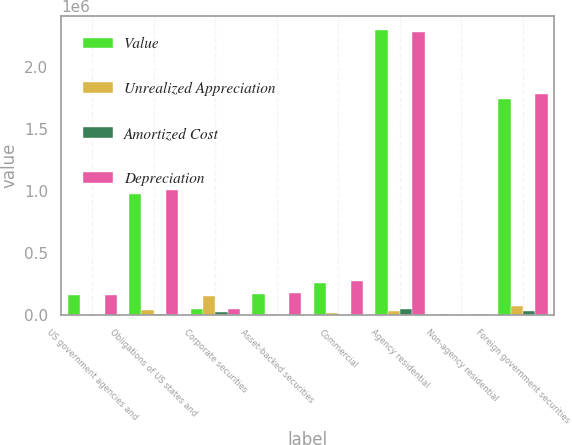Convert chart. <chart><loc_0><loc_0><loc_500><loc_500><stacked_bar_chart><ecel><fcel>US government agencies and<fcel>Obligations of US states and<fcel>Corporate securities<fcel>Asset-backed securities<fcel>Commercial<fcel>Agency residential<fcel>Non-agency residential<fcel>Foreign government securities<nl><fcel>Value<fcel>160013<fcel>970735<fcel>45495<fcel>169980<fcel>254765<fcel>2.29472e+06<fcel>4816<fcel>1.74034e+06<nl><fcel>Unrealized Appreciation<fcel>2690<fcel>40815<fcel>155619<fcel>3485<fcel>16683<fcel>34509<fcel>229<fcel>69779<nl><fcel>Amortized Cost<fcel>1678<fcel>9022<fcel>27090<fcel>422<fcel>1007<fcel>50175<fcel>226<fcel>29347<nl><fcel>Depreciation<fcel>161025<fcel>1.00253e+06<fcel>45495<fcel>173043<fcel>270441<fcel>2.27905e+06<fcel>4819<fcel>1.78077e+06<nl></chart> 